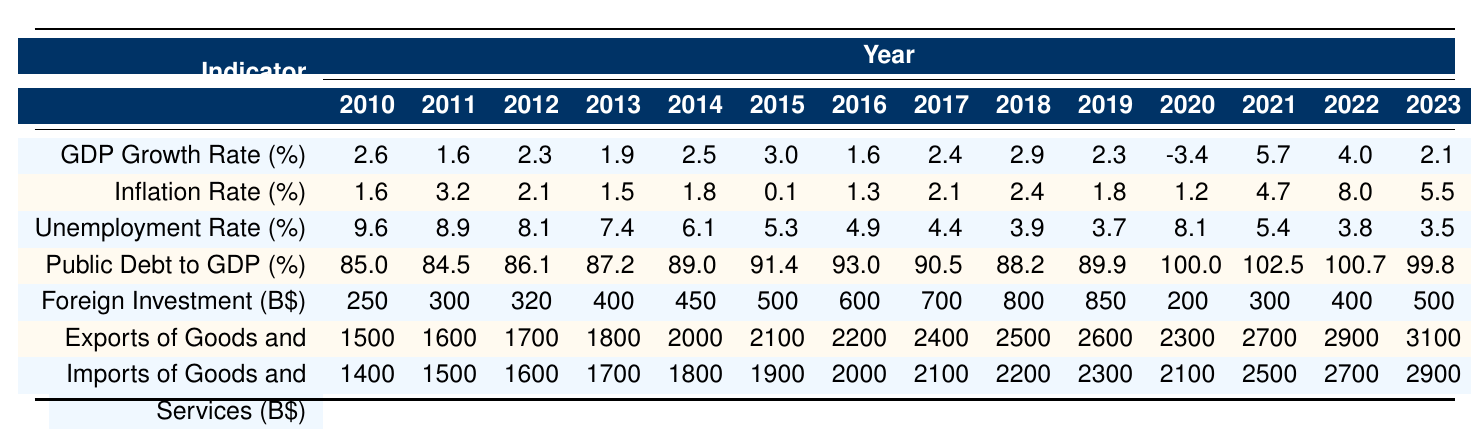What was the GDP growth rate in 2015? The table shows the GDP growth rate for each year. For 2015, it is directly listed as 3.0%.
Answer: 3.0% What is the average inflation rate from 2010 to 2023? To find the average inflation rate, add all the inflation rates from 2010 to 2023, which total 40.9% (1.6 + 3.2 + 2.1 + 1.5 + 1.8 + 0.1 + 1.3 + 2.1 + 2.4 + 1.8 + 1.2 + 4.7 + 8.0 + 5.5), and divide by the number of years (14): 40.9 / 14 = 2.93%.
Answer: 2.93% What year had the highest unemployment rate? Looking at the unemployment rates for each year, 2010 has the highest recorded rate at 9.6%.
Answer: 2010 Did the public debt to GDP percentage increase or decrease from 2019 to 2021? The public debt to GDP was 89.9% in 2019 and increased to 102.5% in 2021, indicating a rise.
Answer: Increase In which year did foreign investment surpass 600 billion dollars for the first time? The data shows that foreign investment reached 600 billion dollars in 2016 and then increased in subsequent years, making 2016 the first year it surpassed that amount.
Answer: 2016 What was the difference between imports and exports in 2020? For 2020, exports were 2300 billion dollars and imports were 2100 billion dollars. The difference is calculated as 2300 - 2100 = 200 billion dollars.
Answer: 200 billion dollars Was the inflation rate higher in 2022 or in 2023? In 2022, the inflation rate is 8.0%, while in 2023 it is 5.5%. Comparing these, 8.0% is higher.
Answer: 2022 What was the change in GDP growth rate from 2019 to 2020? The GDP growth rate decreased from 2.3% in 2019 to -3.4% in 2020. The change can be calculated as -3.4 - 2.3 = -5.7%.
Answer: -5.7% Identify the year with the lowest inflation rate from 2010 to 2023. By examining the inflation rates, we find that 2015 had the lowest rate at 0.1%.
Answer: 2015 What was the total amount of exports from 2010 to 2023? To find the total amount of exports, sum the exports for each year, which equals 36,600 billion dollars (1500 + 1600 + 1700 + 1800 + 2000 + 2100 + 2200 + 2400 + 2500 + 2600 + 2300 + 2700 + 2900 + 3100).
Answer: 36,600 billion dollars 